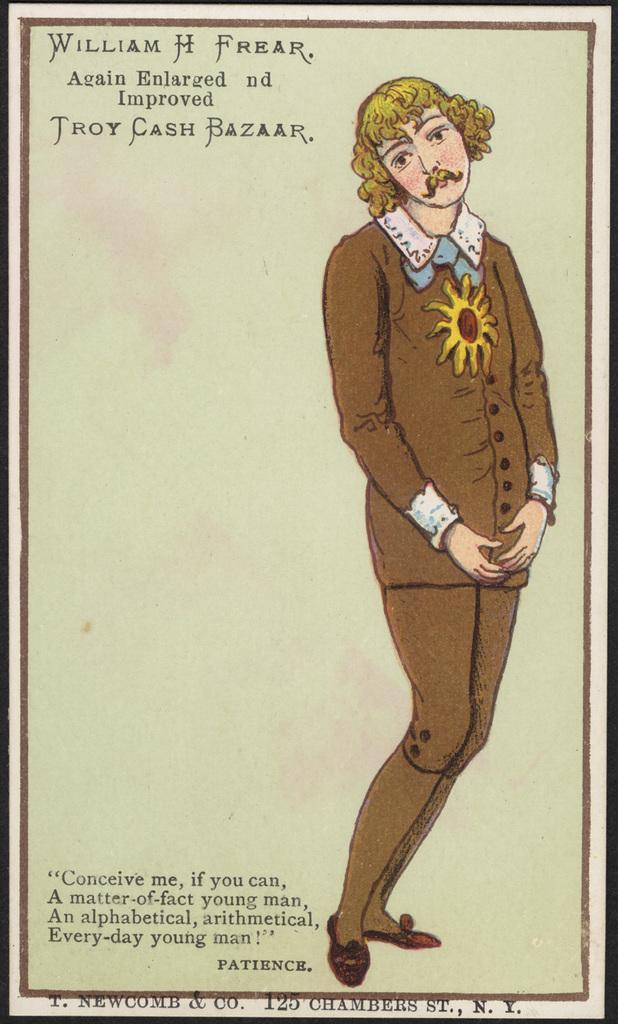What is present in the image that is related to writing or reading? There is a paper in the image. Where is the man located in the image? The man is standing on the right side of the image. Can you describe the text visible in the image? Text is visible at the bottom and top of the image. What is the level of fog in the image? There is no fog present in the image. Is there a meeting taking place in the image? The image does not depict a meeting or any indication of one. 